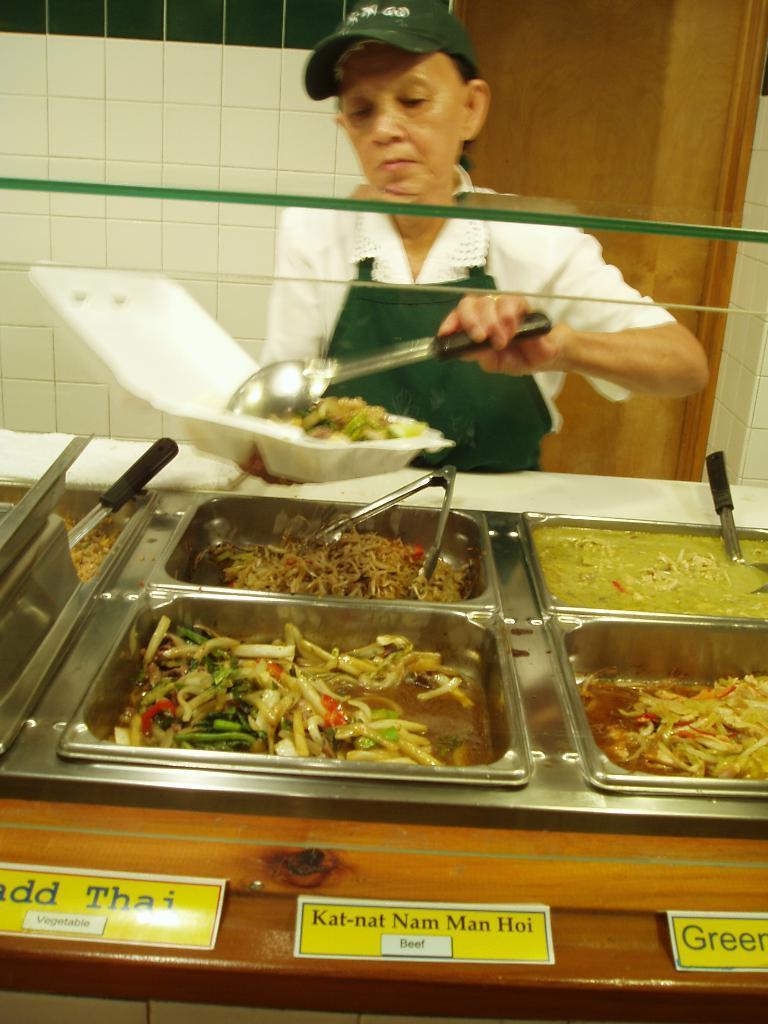Can you describe this image briefly? In the middle of the image we can see a woman, she is holding a plate and a spoon, in front of her we can find food in the bowls, at the bottom of the image we can see name boards. 